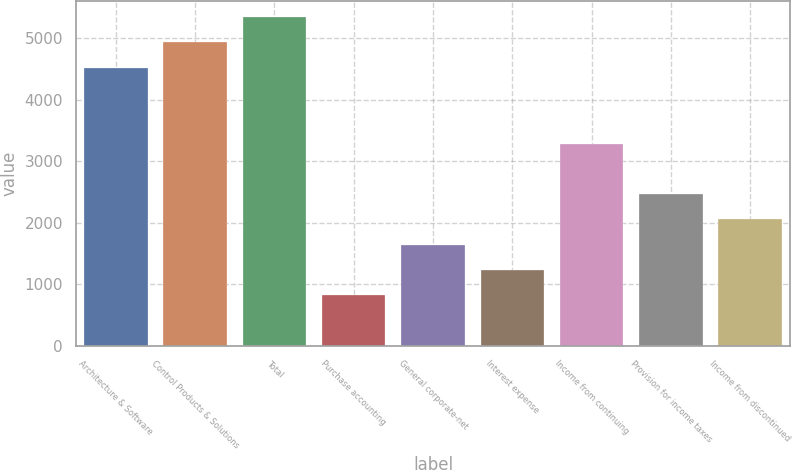Convert chart. <chart><loc_0><loc_0><loc_500><loc_500><bar_chart><fcel>Architecture & Software<fcel>Control Products & Solutions<fcel>Total<fcel>Purchase accounting<fcel>General corporate-net<fcel>Interest expense<fcel>Income from continuing<fcel>Provision for income taxes<fcel>Income from discontinued<nl><fcel>4522.59<fcel>4933.69<fcel>5344.79<fcel>822.69<fcel>1644.89<fcel>1233.79<fcel>3289.29<fcel>2467.09<fcel>2055.99<nl></chart> 